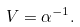<formula> <loc_0><loc_0><loc_500><loc_500>V = \alpha ^ { - 1 } .</formula> 